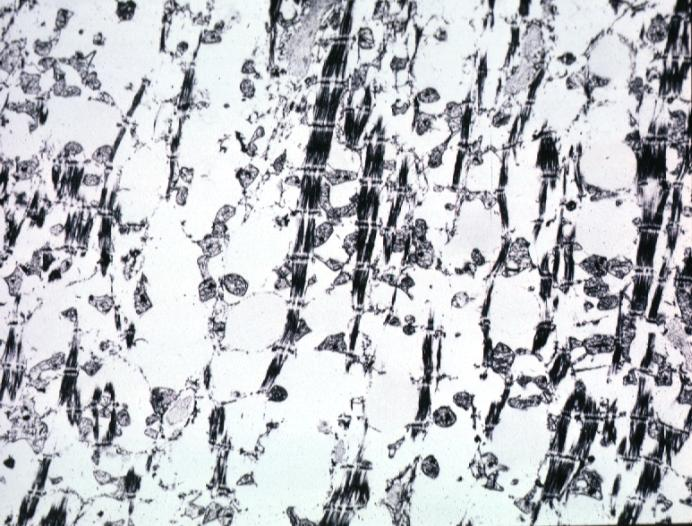does lesion of myocytolysis contain not lipid?
Answer the question using a single word or phrase. Yes 